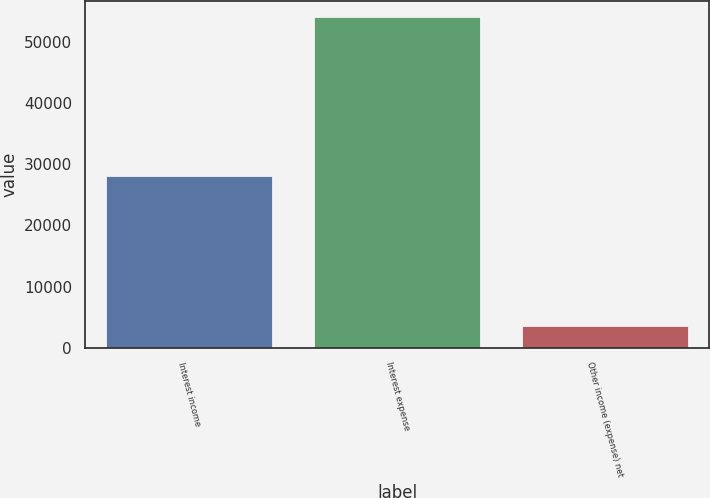<chart> <loc_0><loc_0><loc_500><loc_500><bar_chart><fcel>Interest income<fcel>Interest expense<fcel>Other income (expense) net<nl><fcel>28079<fcel>54035<fcel>3597<nl></chart> 